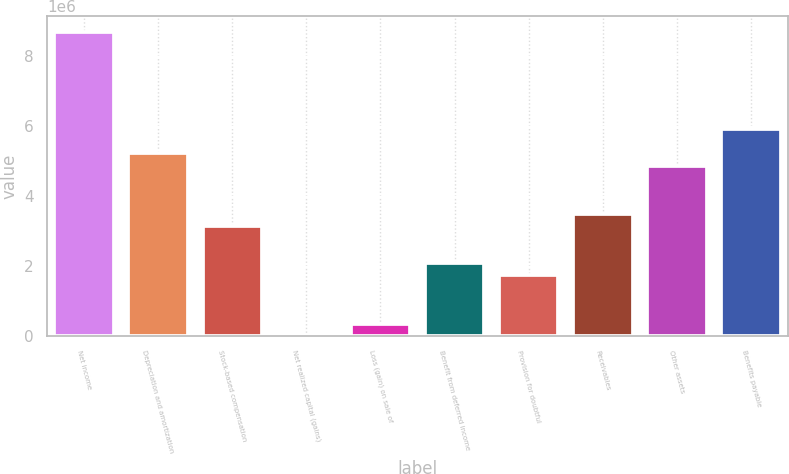Convert chart. <chart><loc_0><loc_0><loc_500><loc_500><bar_chart><fcel>Net income<fcel>Depreciation and amortization<fcel>Stock-based compensation<fcel>Net realized capital (gains)<fcel>Loss (gain) on sale of<fcel>Benefit from deferred income<fcel>Provision for doubtful<fcel>Receivables<fcel>Other assets<fcel>Benefits payable<nl><fcel>8.70408e+06<fcel>5.22711e+06<fcel>3.14093e+06<fcel>11668<fcel>359364<fcel>2.09785e+06<fcel>1.75015e+06<fcel>3.48863e+06<fcel>4.87942e+06<fcel>5.92251e+06<nl></chart> 